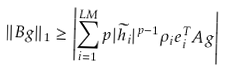<formula> <loc_0><loc_0><loc_500><loc_500>\| { B g } \| _ { 1 } \geq \left | \sum _ { i = 1 } ^ { L M } p | \widetilde { h } _ { i } | ^ { p - 1 } \rho _ { i } { e } _ { i } ^ { T } { A g } \right |</formula> 